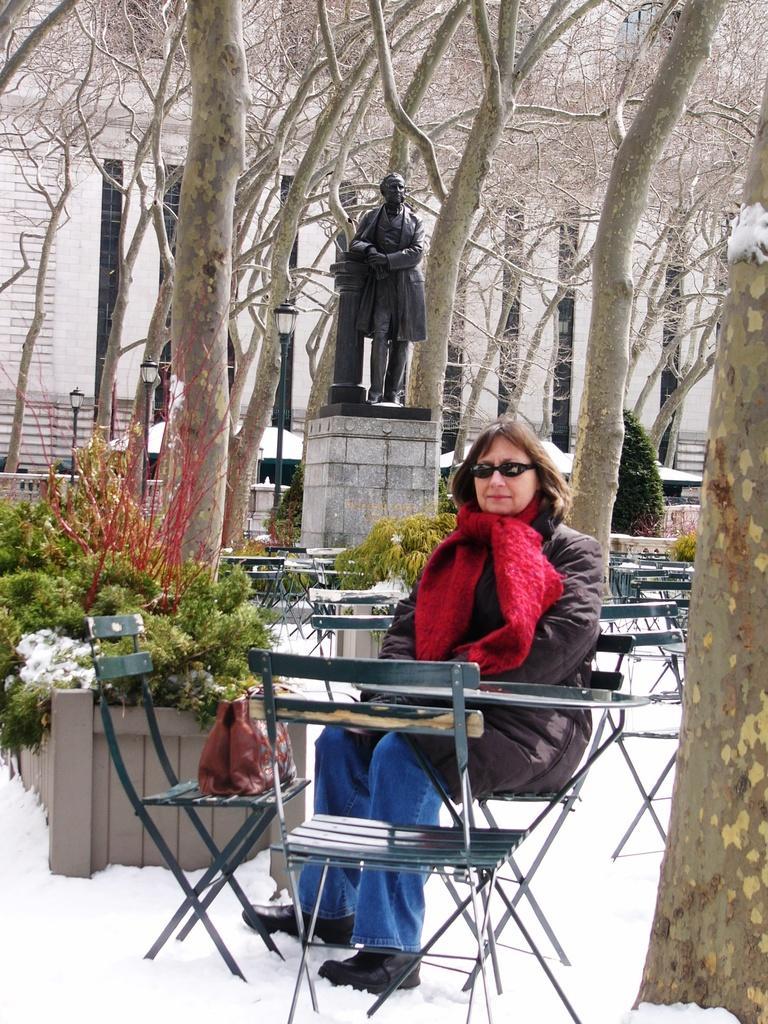Could you give a brief overview of what you see in this image? This person sitting on the chair and wear glasses. We can see chairs and table,on the chair there is a bag. On the background we can see building,trees,plants,statue. This is snow. 